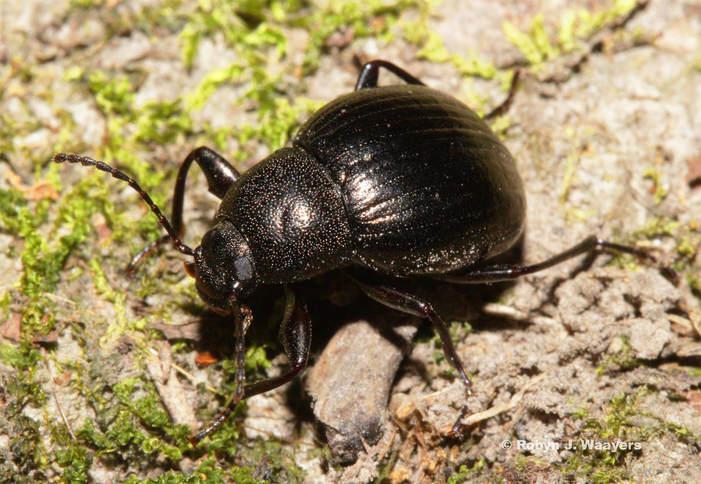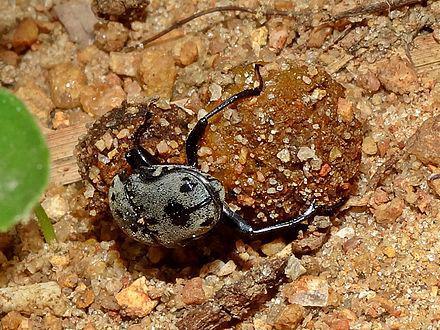The first image is the image on the left, the second image is the image on the right. Given the left and right images, does the statement "There are at most two scarab beetles." hold true? Answer yes or no. Yes. The first image is the image on the left, the second image is the image on the right. Assess this claim about the two images: "The left image contains two beetles.". Correct or not? Answer yes or no. No. 